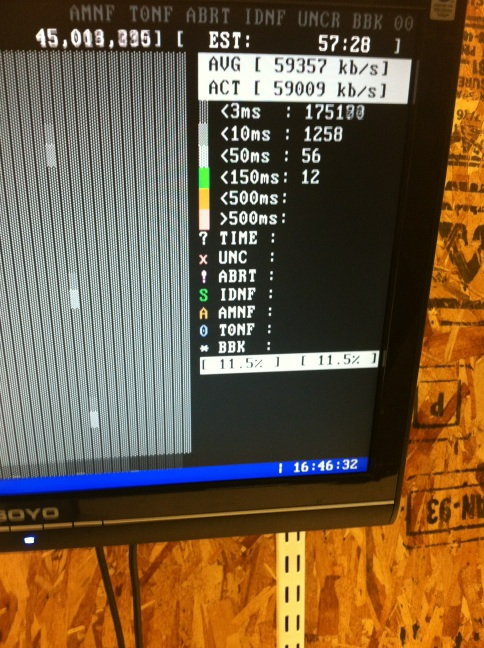Can you explain what the different categories like 'UNC', 'ABRT', and 'IDNF' on the screen might represent? While specific details would depend on the context of the application, generally, 'UNC' might refer to uncorrected errors, 'ABRT' could indicate aborted connections or processes, and 'IDNF' might stand for identifier not found. These categories likely relate to network or data errors and statuses. 